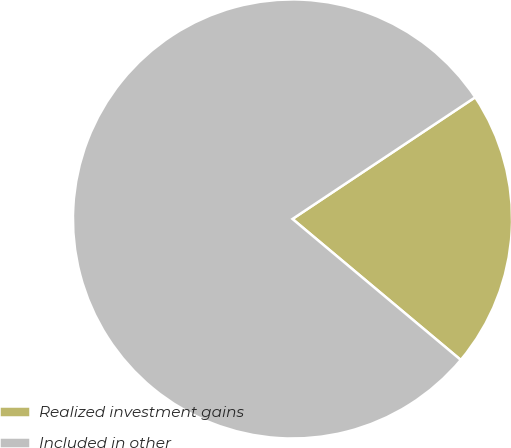Convert chart to OTSL. <chart><loc_0><loc_0><loc_500><loc_500><pie_chart><fcel>Realized investment gains<fcel>Included in other<nl><fcel>20.45%<fcel>79.55%<nl></chart> 